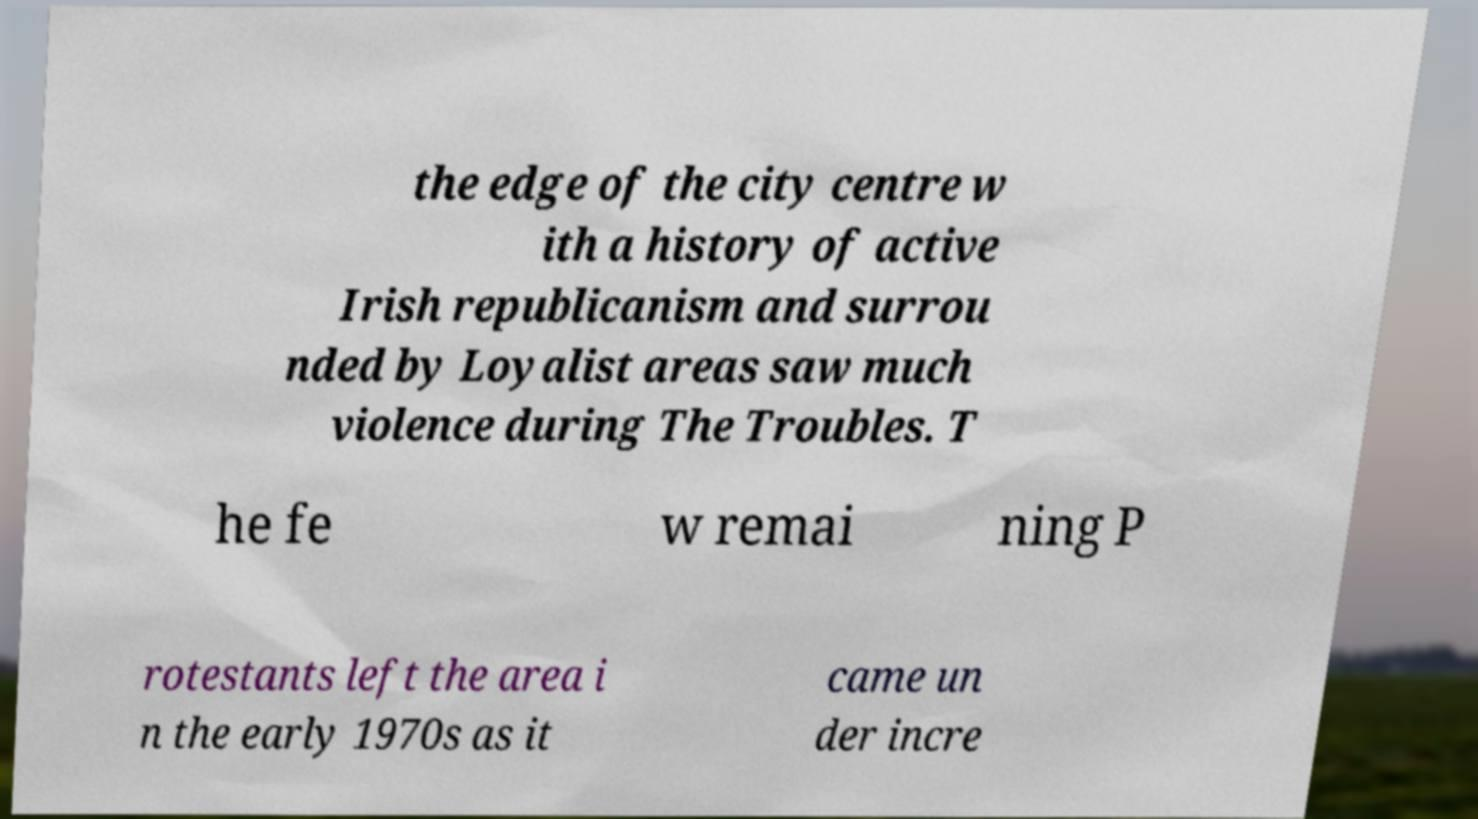Please identify and transcribe the text found in this image. the edge of the city centre w ith a history of active Irish republicanism and surrou nded by Loyalist areas saw much violence during The Troubles. T he fe w remai ning P rotestants left the area i n the early 1970s as it came un der incre 